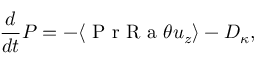<formula> <loc_0><loc_0><loc_500><loc_500>\frac { d } { d t } P = - \langle P r R a \theta u _ { z } \rangle - D _ { \kappa } ,</formula> 